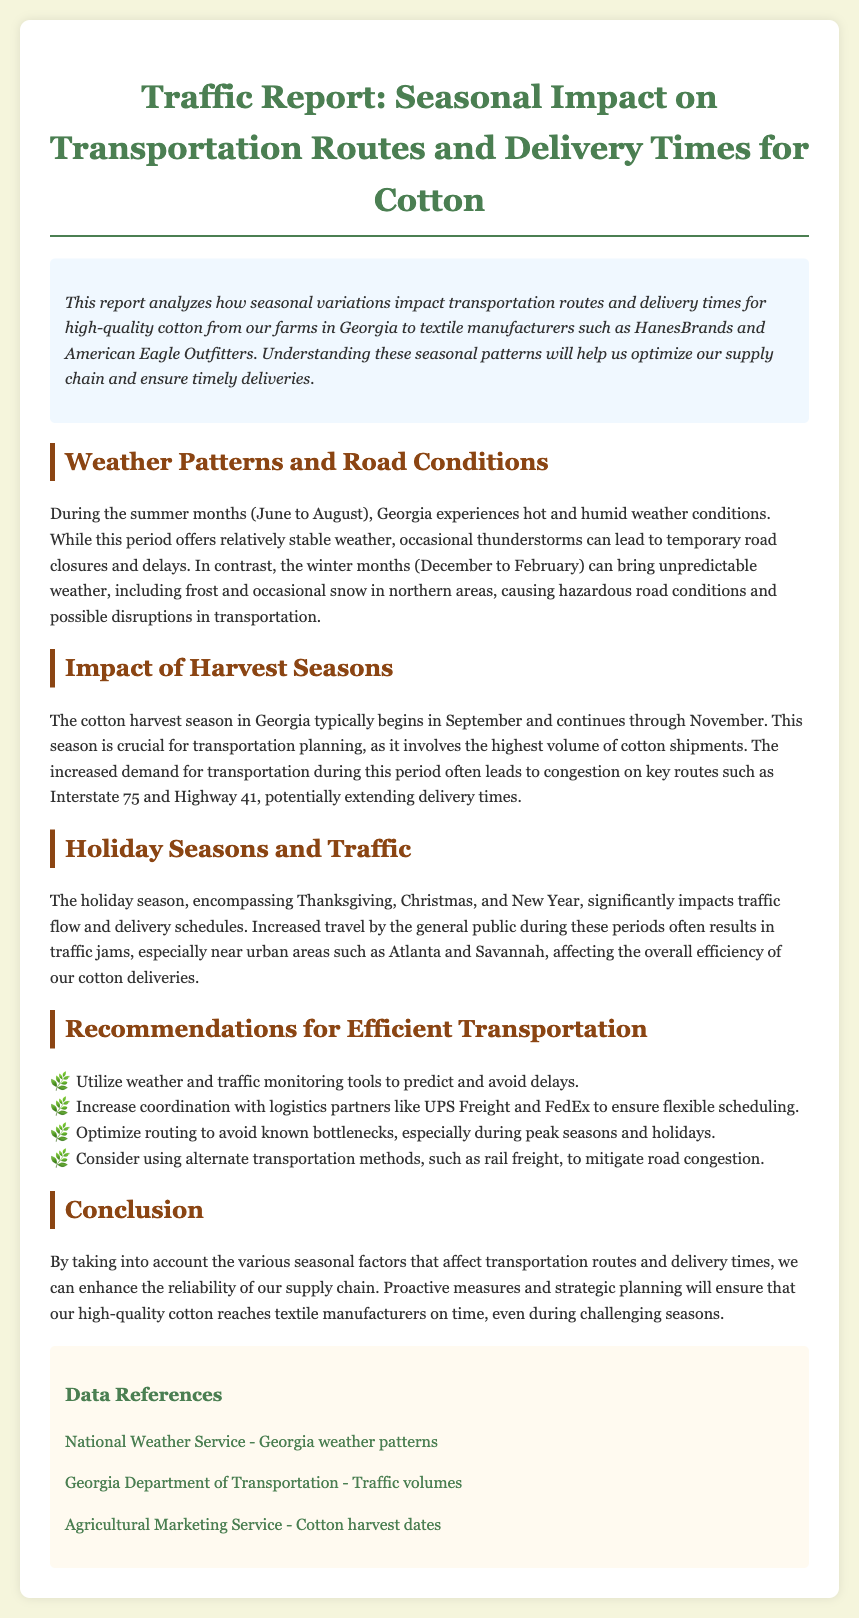What is the primary subject of the report? The report primarily discusses the seasonal impact on transportation routes and delivery times for transporting cotton.
Answer: Seasonal impact on transportation routes and delivery times for cotton During which months does Georgia's cotton harvest season typically occur? The document states that the cotton harvest season in Georgia typically begins in September and continues through November.
Answer: September to November What is the weather condition during summer months in Georgia? The report describes summer months in Georgia as experiencing hot and humid weather conditions.
Answer: Hot and humid Which transportation routes are mentioned as experiencing congestion during the harvest season? The document specifies that congestion often occurs on key routes such as Interstate 75 and Highway 41 during the harvest season.
Answer: Interstate 75 and Highway 41 What holiday seasons are noted to significantly impact traffic flow? The report mentions that the holiday season, encompassing Thanksgiving, Christmas, and New Year, significantly impacts traffic flow.
Answer: Thanksgiving, Christmas, and New Year What recommendation is given to avoid delays? One recommendation provided in the report is to utilize weather and traffic monitoring tools to predict and avoid delays.
Answer: Utilize weather and traffic monitoring tools How does winter weather affect transportation in Georgia? The document states that winter months can bring unpredictable weather, including frost and occasional snow, causing hazardous road conditions.
Answer: Hazardous road conditions What is the purpose of optimizing routing according to the report? The purpose of optimizing routing, as noted in the document, is to avoid known bottlenecks during peak seasons and holidays.
Answer: To avoid known bottlenecks 